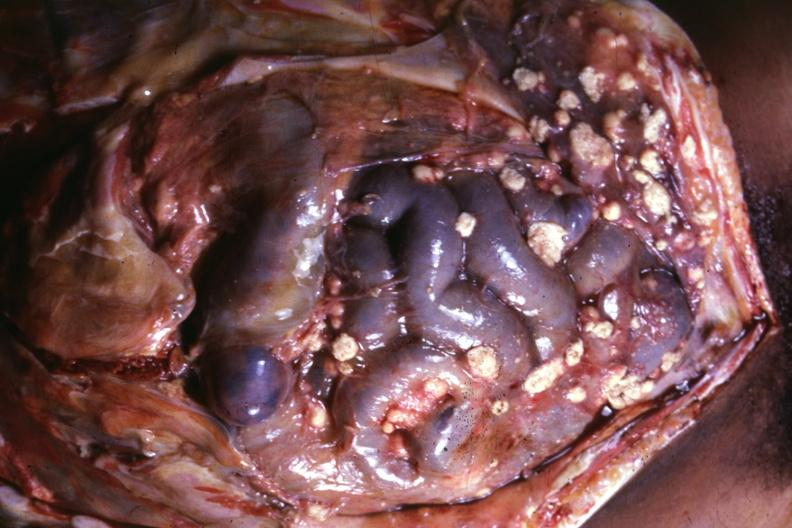does this image show opened abdomen with large lesions typical?
Answer the question using a single word or phrase. Yes 